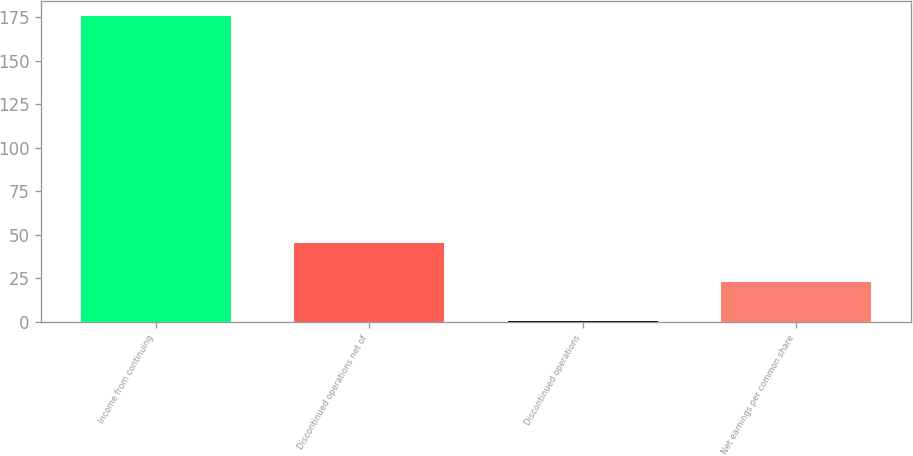Convert chart. <chart><loc_0><loc_0><loc_500><loc_500><bar_chart><fcel>Income from continuing<fcel>Discontinued operations net of<fcel>Discontinued operations<fcel>Net earnings per common share<nl><fcel>175.6<fcel>45.4<fcel>0.42<fcel>22.91<nl></chart> 